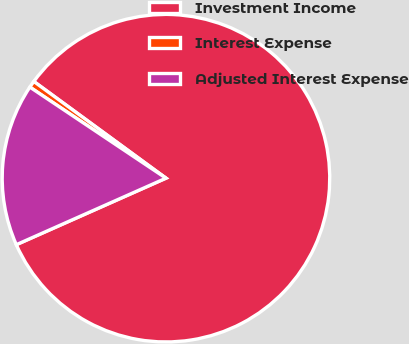<chart> <loc_0><loc_0><loc_500><loc_500><pie_chart><fcel>Investment Income<fcel>Interest Expense<fcel>Adjusted Interest Expense<nl><fcel>83.29%<fcel>0.67%<fcel>16.04%<nl></chart> 